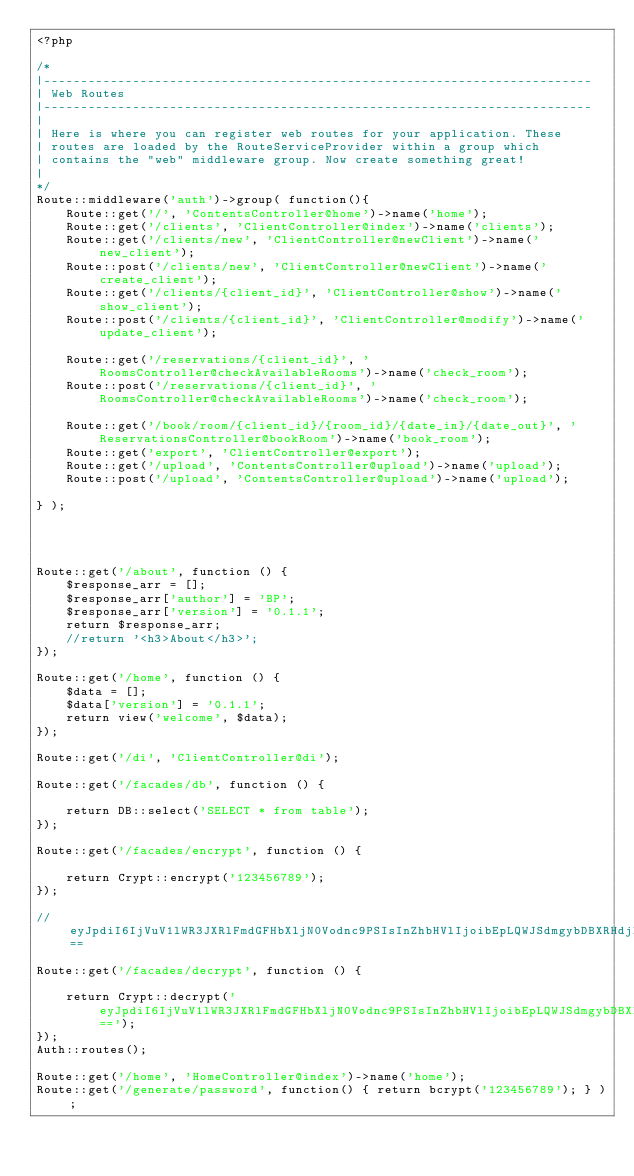Convert code to text. <code><loc_0><loc_0><loc_500><loc_500><_PHP_><?php

/*
|--------------------------------------------------------------------------
| Web Routes
|--------------------------------------------------------------------------
|
| Here is where you can register web routes for your application. These
| routes are loaded by the RouteServiceProvider within a group which
| contains the "web" middleware group. Now create something great!
|
*/
Route::middleware('auth')->group( function(){
    Route::get('/', 'ContentsController@home')->name('home');
    Route::get('/clients', 'ClientController@index')->name('clients');
    Route::get('/clients/new', 'ClientController@newClient')->name('new_client');
    Route::post('/clients/new', 'ClientController@newClient')->name('create_client');
    Route::get('/clients/{client_id}', 'ClientController@show')->name('show_client');
    Route::post('/clients/{client_id}', 'ClientController@modify')->name('update_client');

    Route::get('/reservations/{client_id}', 'RoomsController@checkAvailableRooms')->name('check_room');
    Route::post('/reservations/{client_id}', 'RoomsController@checkAvailableRooms')->name('check_room');

    Route::get('/book/room/{client_id}/{room_id}/{date_in}/{date_out}', 'ReservationsController@bookRoom')->name('book_room');
    Route::get('export', 'ClientController@export');
    Route::get('/upload', 'ContentsController@upload')->name('upload');
    Route::post('/upload', 'ContentsController@upload')->name('upload');

} );




Route::get('/about', function () {
    $response_arr = [];
    $response_arr['author'] = 'BP';
    $response_arr['version'] = '0.1.1';
    return $response_arr;
    //return '<h3>About</h3>';
});

Route::get('/home', function () {
    $data = [];
    $data['version'] = '0.1.1';
    return view('welcome', $data);
});

Route::get('/di', 'ClientController@di');

Route::get('/facades/db', function () {
    
    return DB::select('SELECT * from table');
});

Route::get('/facades/encrypt', function () {
    
    return Crypt::encrypt('123456789');
});

//eyJpdiI6IjVuV1lWR3JXRlFmdGFHbXljN0Vodnc9PSIsInZhbHVlIjoibEpLQWJSdmgybDBXRHdjNDJadERwM0lZRWlLZnA5d2hcL1wvMHdCNEpCSklFPSIsIm1hYyI6ImE1NDQxZDhiMTAyNjQyNTZkOTZlY2NkZTdmNmIxYThhNjU1OTI2MGI2OTFmYWUxNmRlODk1ZDNiODgxMTY3YzAifQ==

Route::get('/facades/decrypt', function () {
    
    return Crypt::decrypt('eyJpdiI6IjVuV1lWR3JXRlFmdGFHbXljN0Vodnc9PSIsInZhbHVlIjoibEpLQWJSdmgybDBXRHdjNDJadERwM0lZRWlLZnA5d2hcL1wvMHdCNEpCSklFPSIsIm1hYyI6ImE1NDQxZDhiMTAyNjQyNTZkOTZlY2NkZTdmNmIxYThhNjU1OTI2MGI2OTFmYWUxNmRlODk1ZDNiODgxMTY3YzAifQ==');
});
Auth::routes();

Route::get('/home', 'HomeController@index')->name('home');
Route::get('/generate/password', function() { return bcrypt('123456789'); } );
</code> 